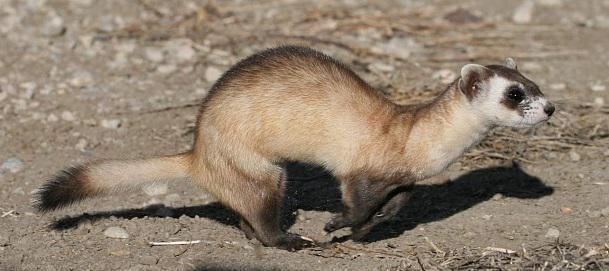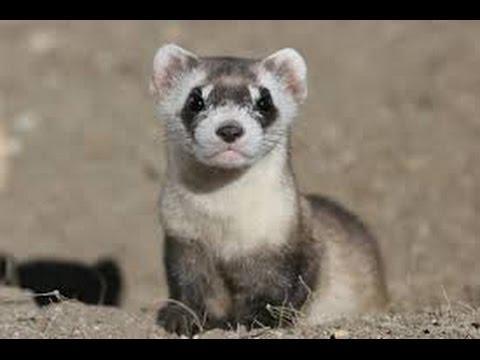The first image is the image on the left, the second image is the image on the right. Considering the images on both sides, is "One of the weasels is facing left." valid? Answer yes or no. No. 